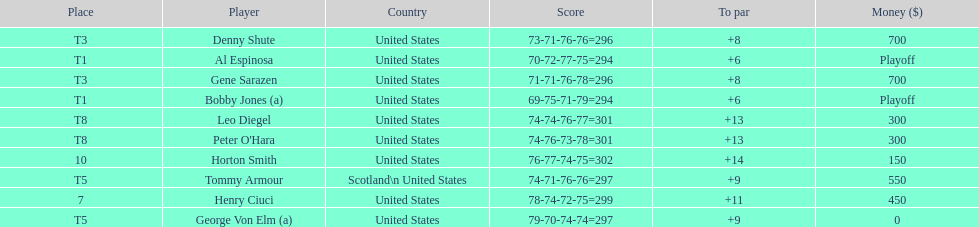How many players represented scotland? 1. 